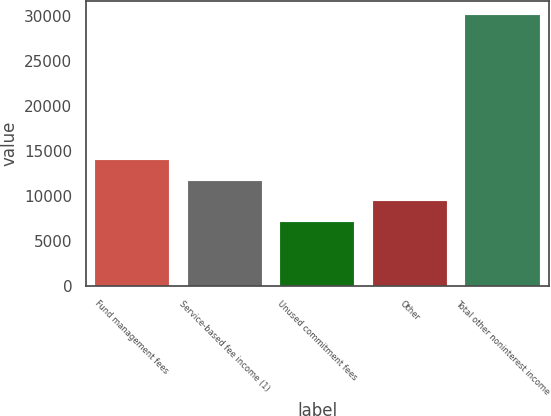Convert chart. <chart><loc_0><loc_0><loc_500><loc_500><bar_chart><fcel>Fund management fees<fcel>Service-based fee income (1)<fcel>Unused commitment fees<fcel>Other<fcel>Total other noninterest income<nl><fcel>14013<fcel>11707<fcel>7095<fcel>9401<fcel>30155<nl></chart> 